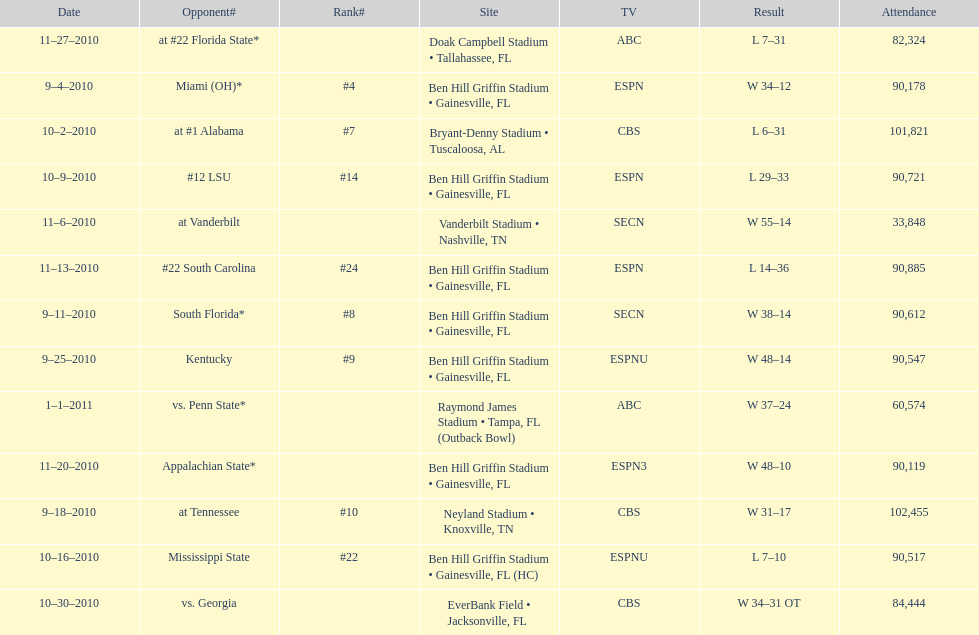What is the number of games played in teh 2010-2011 season 13. 